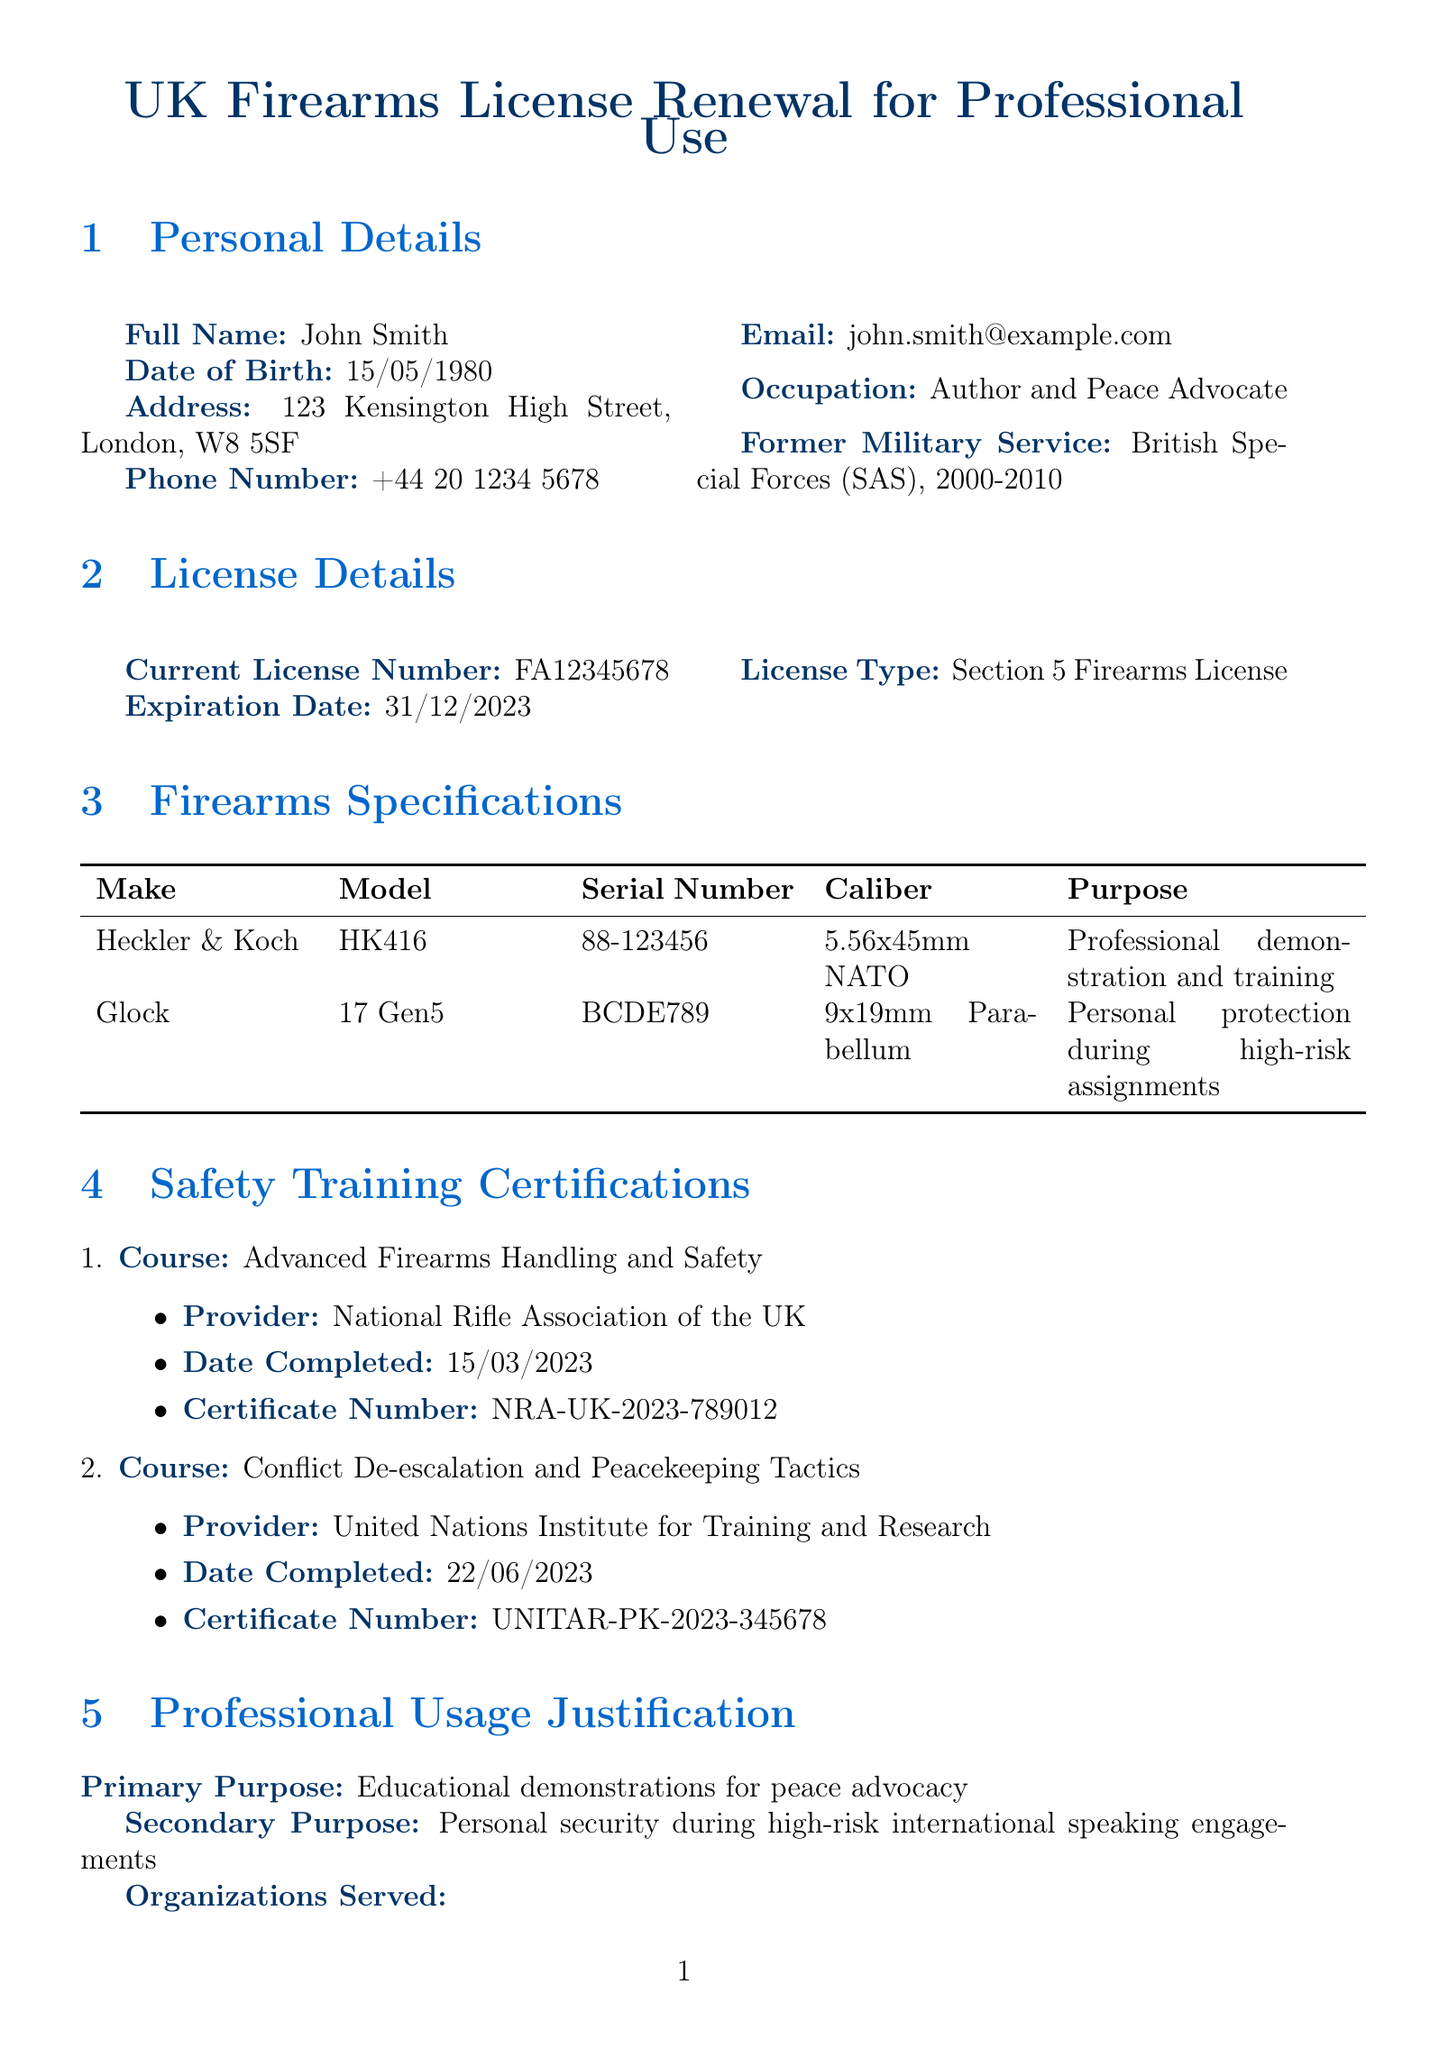What is the full name of the applicant? The full name of the applicant is found in the personal details section of the document.
Answer: John Smith What is the expiration date of the current license? The expiration date of the current license is listed in the license details section.
Answer: 31/12/2023 What is the primary purpose for the firearms usage? The primary purpose is specified in the professional usage justification section of the document.
Answer: Educational demonstrations for peace advocacy Who is the provider of the safety training course "Advanced Firearms Handling and Safety"? The provider's name is detailed under the safety training certifications section for that course.
Answer: National Rifle Association of the UK What is the result of the mental health assessment? The result is mentioned in the mental health assessment section of the document.
Answer: Fit to possess firearms What is the storage location of the firearms? The storage location can be found in the storage and security section of the document.
Answer: Secured safe at residential address What is the model of the Glock? The model is listed under the firearms specifications section of the document.
Answer: 17 Gen5 Who conducted the mental health assessment? The name of the assessor is mentioned in the mental health assessment section.
Answer: Dr. Emily Johnson What type of firearms license is being renewed? The license type is specified in the license details section of the document.
Answer: Section 5 Firearms License 